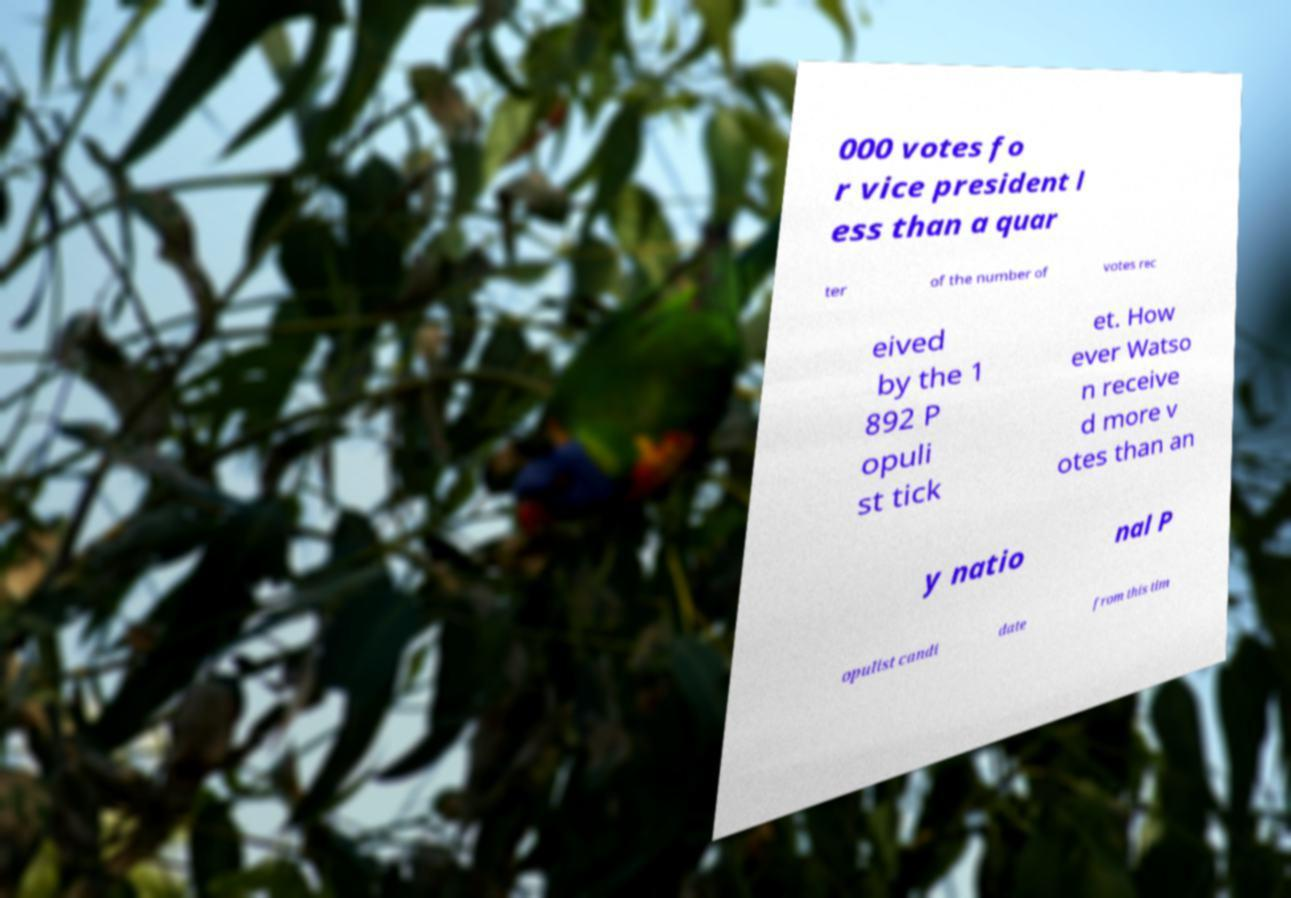Please read and relay the text visible in this image. What does it say? 000 votes fo r vice president l ess than a quar ter of the number of votes rec eived by the 1 892 P opuli st tick et. How ever Watso n receive d more v otes than an y natio nal P opulist candi date from this tim 